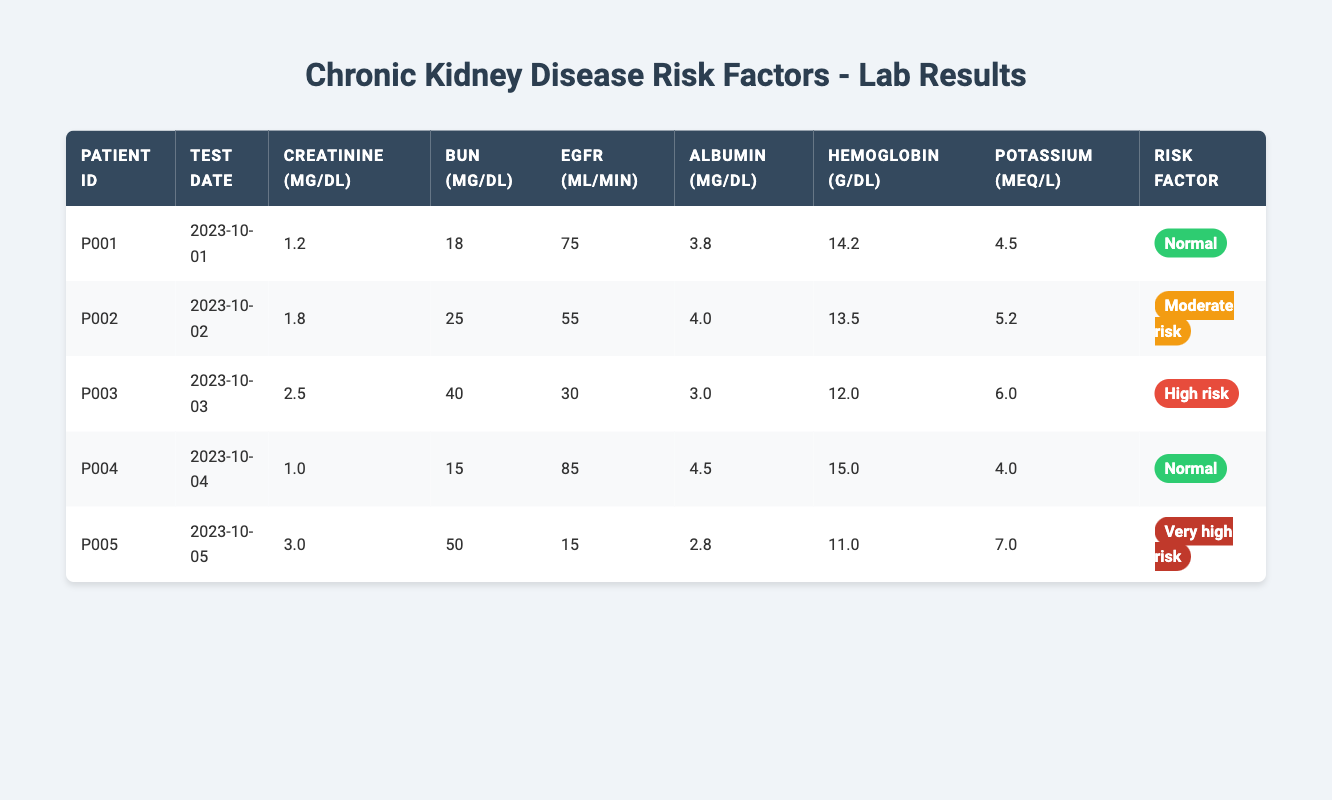What is the creatinine level of Patient P002? According to the table, the creatinine level for Patient P002 is listed directly under the "Creatinine (mg/dL)" column for that patient. The value is 1.8 mg/dL.
Answer: 1.8 mg/dL Which patient has the highest estimated GFR? The estimated GFR values are found in the "eGFR (mL/min)" column. By comparing the eGFR values for all the patients, Patient P004 has the highest estimated GFR at 85 mL/min.
Answer: P004 Is there a patient with a normal risk factor who has a potassium level greater than 4.0 mEq/L? We look for patients categorized as having a "Normal" risk factor from the "Risk Factor" column and then check their potassium levels in the "Potassium (mEq/L)" column. Patient P001 has a potassium level of 4.5 mEq/L, which is greater than 4.0 mEq/L. Thus, the answer is yes.
Answer: Yes Calculate the average Blood Urea Nitrogen level for patients with moderate and high risk factors. First, we identify the patients with moderate ("P002") and high risk ("P003"). Their BUN values are 25 mg/dL and 40 mg/dL, respectively. The average is calculated as (25 + 40) / 2 = 32.5 mg/dL.
Answer: 32.5 mg/dL What is the total hemoglobin level across all patients? The "Hemoglobin (g/dL)" column lists the individual hemoglobin levels of all five patients. Adding these values: 14.2 + 13.5 + 12.0 + 15.0 + 11.0 = 66.7 g/dL.
Answer: 66.7 g/dL Which patients have low creatinine levels of less than 1.5 mg/dL? By inspecting the "Creatinine (mg/dL)" column, Patient P001 has a level of 1.2 mg/dL and Patient P004 has a level of 1.0 mg/dL. These are both below 1.5 mg/dL.
Answer: P001, P004 How many patients have a risk factor of 'Very high risk'? Looking at the "Risk Factor" column, we find that only Patient P005 is classified as 'Very high risk'. Counting this gives us one patient.
Answer: 1 What is the difference in estimated GFR between the highest and lowest values in the table? The highest eGFR is 85 mL/min (P004) and the lowest is 15 mL/min (P005). The difference is calculated as 85 - 15 = 70 mL/min.
Answer: 70 mL/min Is the Blood Urea Nitrogen level of Patient P003 above the average of all patients’ BUN levels? First, we find the BUN levels for each patient: 18, 25, 40, 15, 50, respectively. The average BUN is (18 + 25 + 40 + 15 + 50) / 5 = 29.6 mg/dL. Patient P003 has a BUN of 40 mg/dL, which is above the average.
Answer: Yes 